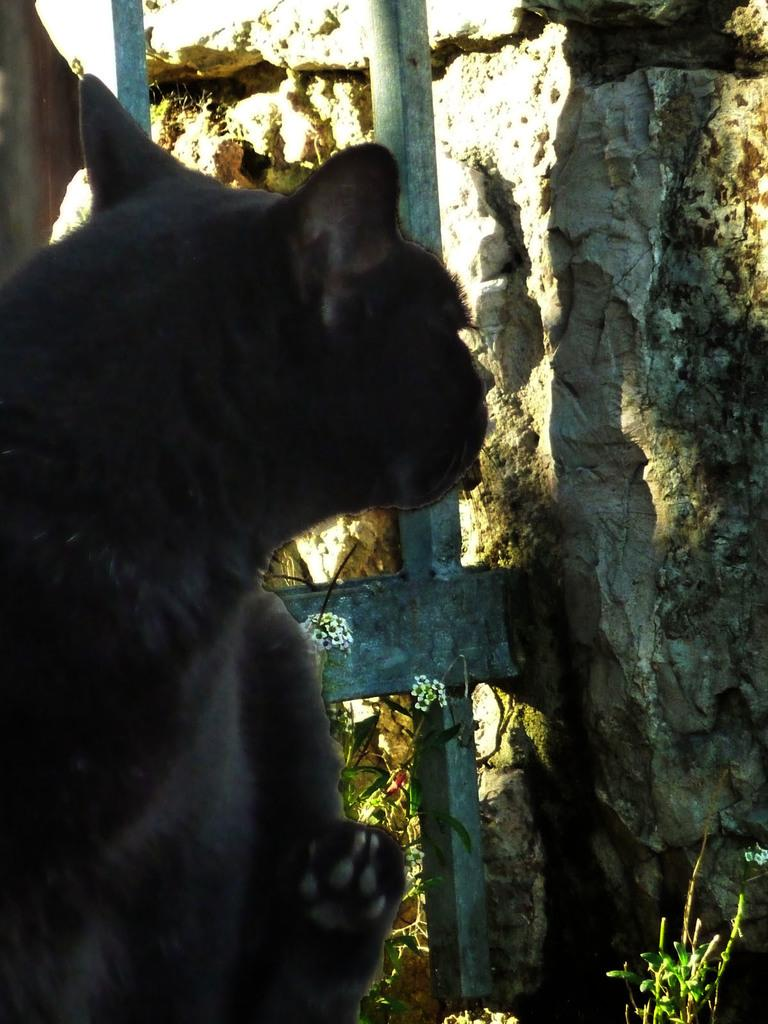What type of animal is present in the image? There is an animal in the image, but its specific type cannot be determined from the provided facts. What object can be seen in the image that might be used for climbing? There is a ladder in the image. What geological feature is visible in the image? There is a rock in the image. What type of vegetation is present in the image? There are plants in the image. What type of string is the animal using to play with its friend in the image? There is no string or friend of the animal present in the image. 